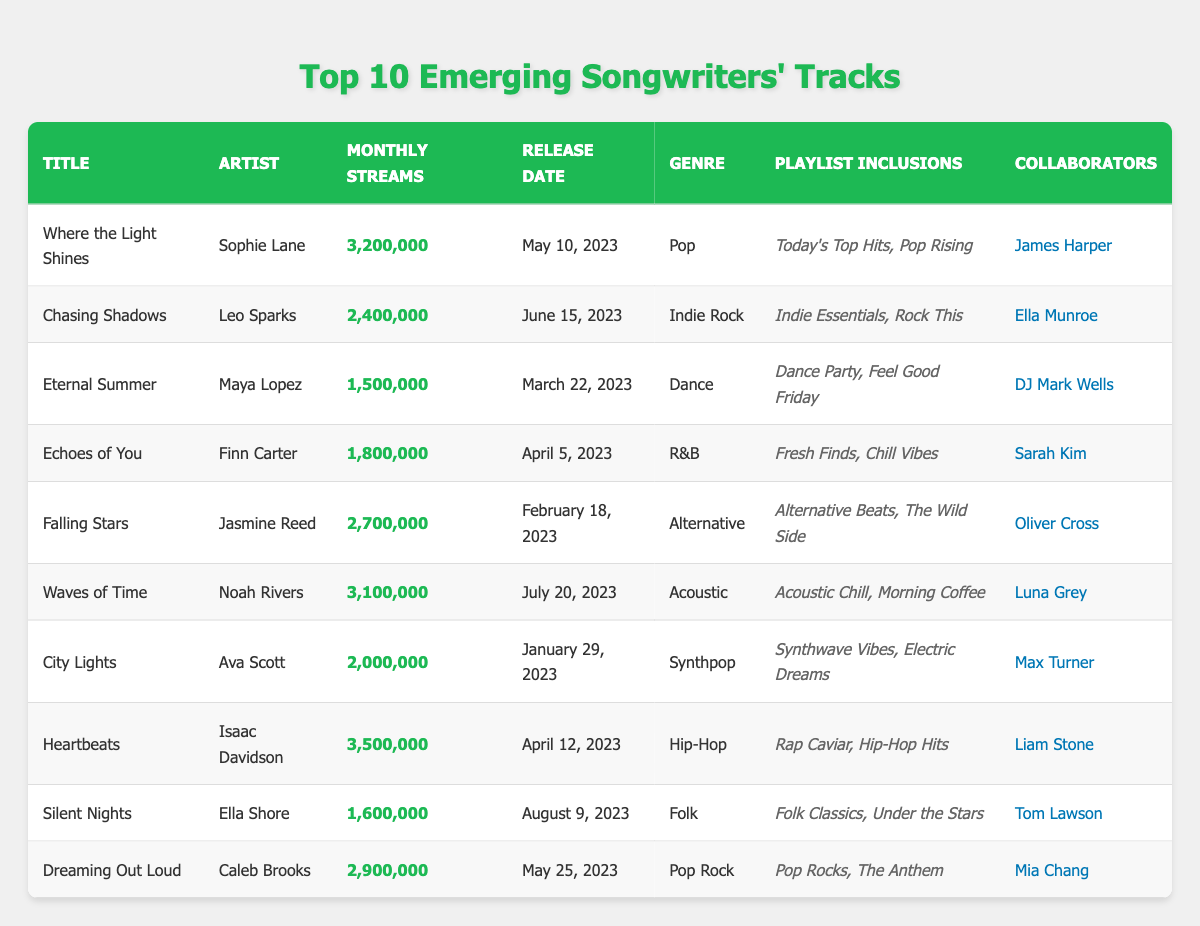What's the title of the track with the highest monthly streams? The table shows that "Heartbeats" by Isaac Davidson has the highest monthly streams, totaling 3,500,000.
Answer: Heartbeats Which track was released on June 15, 2023? By checking the release dates in the table, "Chasing Shadows" by Leo Sparks was released on June 15, 2023.
Answer: Chasing Shadows How many tracks have more than 2 million monthly streams? Reviewing the monthly streams listed, the tracks with over 2 million streams are: "Where the Light Shines," "Chasing Shadows," "Falling Stars," "Waves of Time," "City Lights," "Heartbeats," and "Dreaming Out Loud." This totals 6 tracks.
Answer: 6 What is the average monthly streams of all tracks listed? To find the average, sum the monthly streams: (3,200,000 + 2,400,000 + 1,500,000 + 1,800,000 + 2,700,000 + 3,100,000 + 2,000,000 + 3,500,000 + 1,600,000 + 2,900,000) =  22,400,000. There are 10 tracks, so the average is 22,400,000 / 10 = 2,240,000.
Answer: 2,240,000 Does "Eternal Summer" have a collaborator listed? Looking closely at the table, "Eternal Summer" by Maya Lopez lists DJ Mark Wells as its collaborator. Therefore, the answer is yes.
Answer: Yes Which genre has the most tracks in the list? By inspecting the genre column: Pop, Indie Rock, Dance, R&B, Alternative, Acoustic, Synthpop, Hip-Hop, Folk, and Pop Rock—Pop appears twice (two tracks). No other genre is repeated more than once, thus Pop has the most tracks.
Answer: Pop What are the playlist inclusions for "Waves of Time"? The table states that "Waves of Time" by Noah Rivers is included in "Acoustic Chill" and "Morning Coffee."
Answer: Acoustic Chill, Morning Coffee Identify any track which includes a collaborator with the first name 'James'. The track "Where the Light Shines" features a collaborator named James Harper. Therefore, this track meets the criteria.
Answer: Where the Light Shines What is the difference in monthly streams between "Heartbeats" and "Silent Nights"? "Heartbeats" has 3,500,000 monthly streams and "Silent Nights" has 1,600,000. The difference is 3,500,000 - 1,600,000 = 1,900,000.
Answer: 1,900,000 